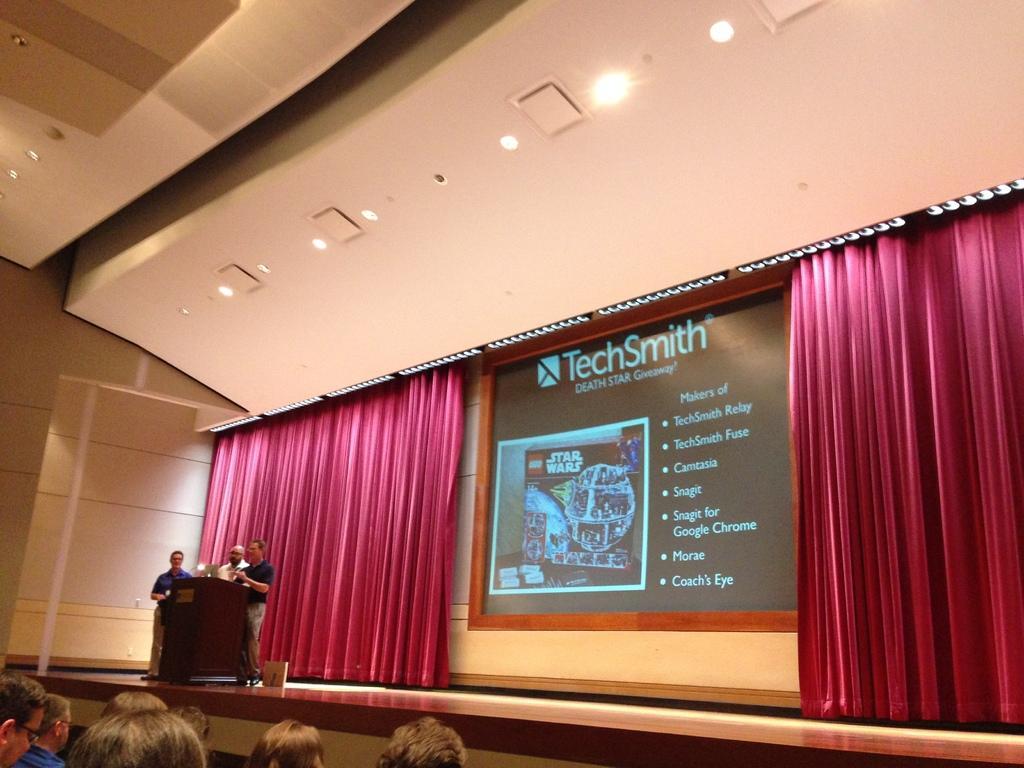Please provide a concise description of this image. This is an inside view of a hall. On the right side, I can see the stage on which three men are standing in front of the podium. At the back of these people I can see a screen and two curtains. At the bottom of the image I can see few people are facing towards the stage. At the top there are some lights. 